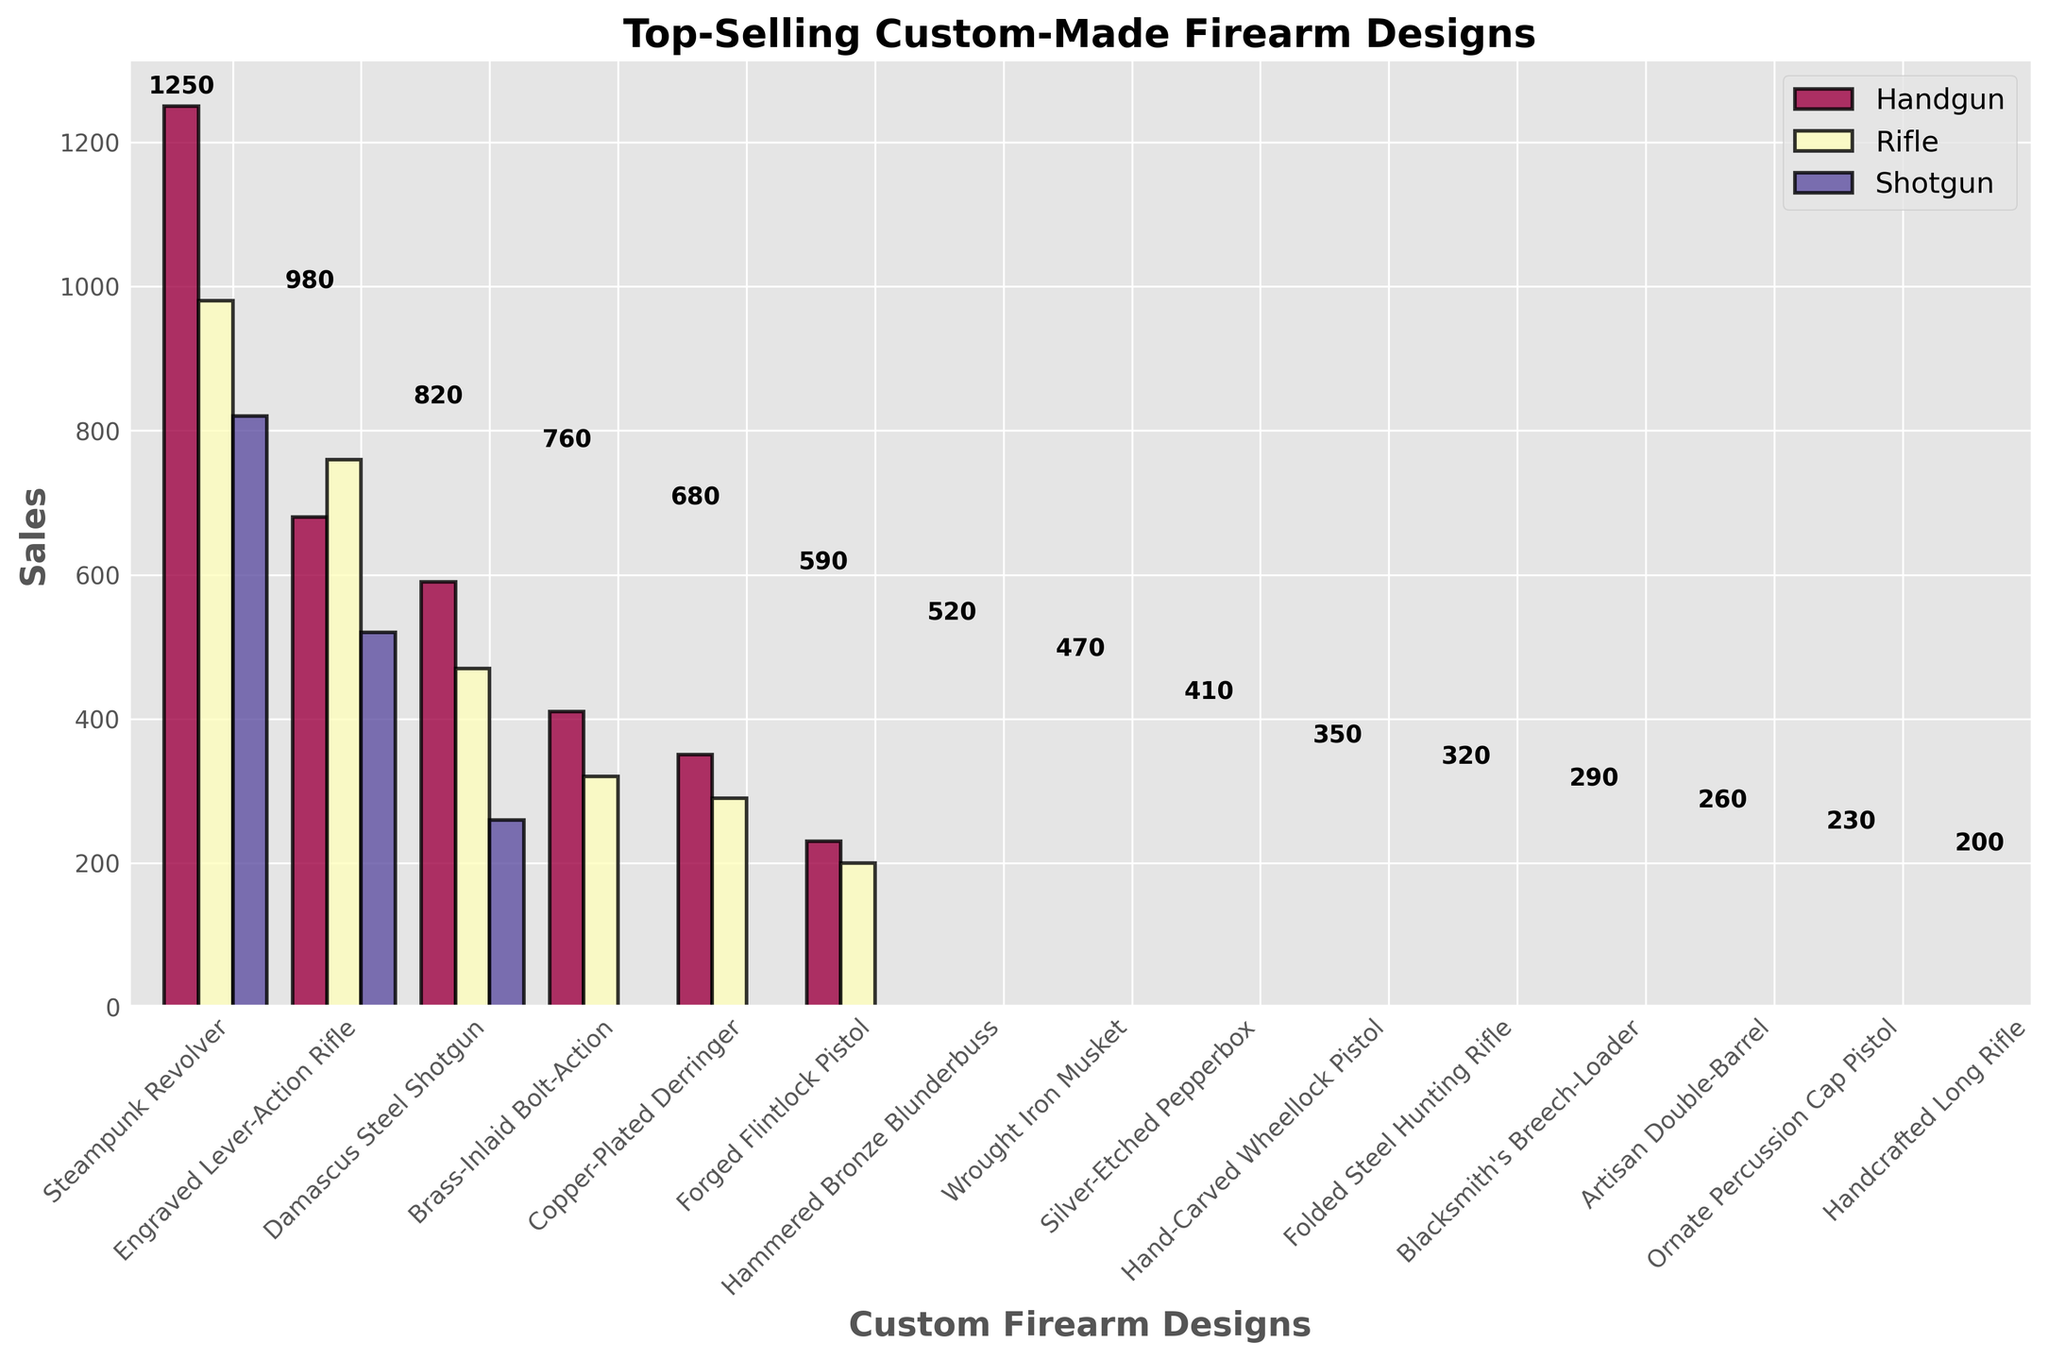Which firearm design has the highest sales? The firearm designs are listed along the x-axis with their sales values depicted by the height of their respective bars. The highest bar represents the design with the highest sales.
Answer: Steampunk Revolver Which category has the lowest cumulative sales? Sum up the sales of every design in each category and compare the totals. Handgun: 1250 + 680 + 590 + 410 + 350 + 230 = 3510, Rifle: 980 + 760 + 470 + 320 + 290 + 200 = 3020, Shotgun: 820 + 520 + 260 = 1600. Shotgun has the lowest cumulative sales.
Answer: Shotgun How many different firearm designs are there in the Rifle category? Count the number of bars for the Rifle category in the plot. The bars will be marked with colors indicating their categories.
Answer: 6 What is the difference in sales between the best-selling handgun and the best-selling shotgun? Identify the best-selling designs in both categories by comparing the heights of the bars within each category. The Steampunk Revolver (Handgun) has 1250 sales, and Damascus Steel Shotgun (Shotgun) has 820 sales. Subtract the sales of the shotgun from the handgun: 1250 - 820 = 430.
Answer: 430 What percentage of total sales is represented by the Engraved Lever-Action Rifle? Total sales is the sum of all the sales values: 1250 + 980 + 820 + 760 + 680 + 590 + 520 + 470 + 410 + 350 + 320 + 290 + 260 + 230 + 200 = 8110. The percentage is (sales of Engraved Lever-Action Rifle / total sales) * 100 = (980 / 8110) * 100 ≈ 12.08%.
Answer: Approximately 12.08% Which design in the Handgun category has the lowest sales? Among the designs in the Handgun category, look for the one with the smallest bar. The Handcrafted Long Rifle (Rifle) has 200, but it is not a Handgun. The correct Handgun answer is Ornate Percussion Cap Pistol with 230 sales.
Answer: Ornate Percussion Cap Pistol Which category has the highest individual design sales? Compare the highest sale value in each category. The Handgun category has the Steampunk Revolver with 1250 sales, which is higher than any individual design in the other categories.
Answer: Handgun What are the sales of the third best-selling rifle? List the rifles in descending order of sales: Engraved Lever-Action Rifle (980), Brass-Inlaid Bolt-Action (760), Wrought Iron Musket (470). The third best-selling rifle is the Wrought Iron Musket with sales of 470.
Answer: 470 